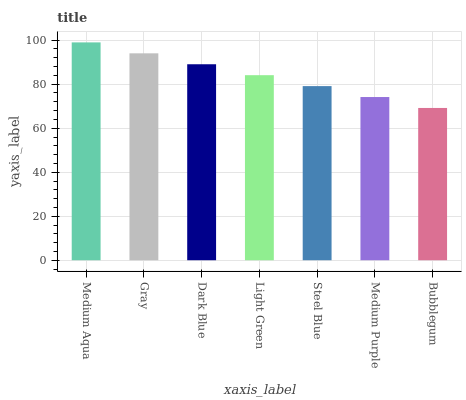Is Bubblegum the minimum?
Answer yes or no. Yes. Is Medium Aqua the maximum?
Answer yes or no. Yes. Is Gray the minimum?
Answer yes or no. No. Is Gray the maximum?
Answer yes or no. No. Is Medium Aqua greater than Gray?
Answer yes or no. Yes. Is Gray less than Medium Aqua?
Answer yes or no. Yes. Is Gray greater than Medium Aqua?
Answer yes or no. No. Is Medium Aqua less than Gray?
Answer yes or no. No. Is Light Green the high median?
Answer yes or no. Yes. Is Light Green the low median?
Answer yes or no. Yes. Is Bubblegum the high median?
Answer yes or no. No. Is Dark Blue the low median?
Answer yes or no. No. 